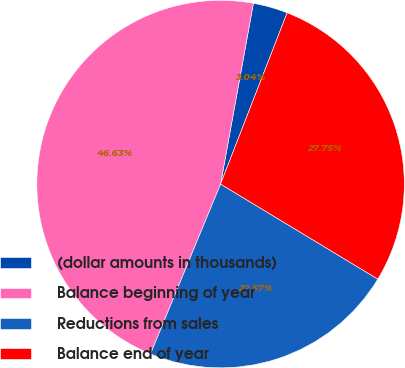Convert chart to OTSL. <chart><loc_0><loc_0><loc_500><loc_500><pie_chart><fcel>(dollar amounts in thousands)<fcel>Balance beginning of year<fcel>Reductions from sales<fcel>Balance end of year<nl><fcel>3.04%<fcel>46.63%<fcel>22.57%<fcel>27.75%<nl></chart> 